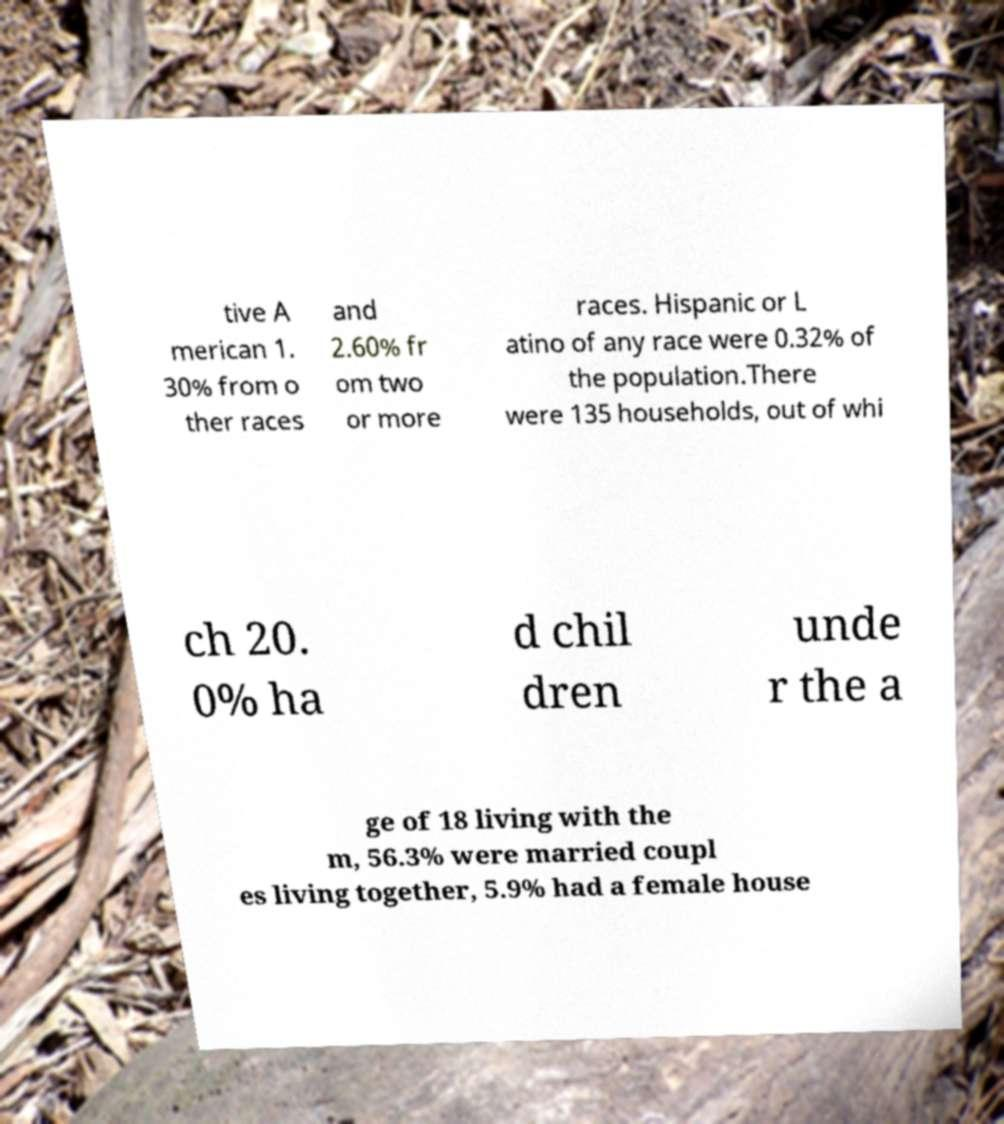Could you extract and type out the text from this image? tive A merican 1. 30% from o ther races and 2.60% fr om two or more races. Hispanic or L atino of any race were 0.32% of the population.There were 135 households, out of whi ch 20. 0% ha d chil dren unde r the a ge of 18 living with the m, 56.3% were married coupl es living together, 5.9% had a female house 